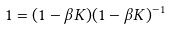<formula> <loc_0><loc_0><loc_500><loc_500>1 = ( 1 - \beta K ) ( 1 - \beta K ) ^ { - 1 }</formula> 